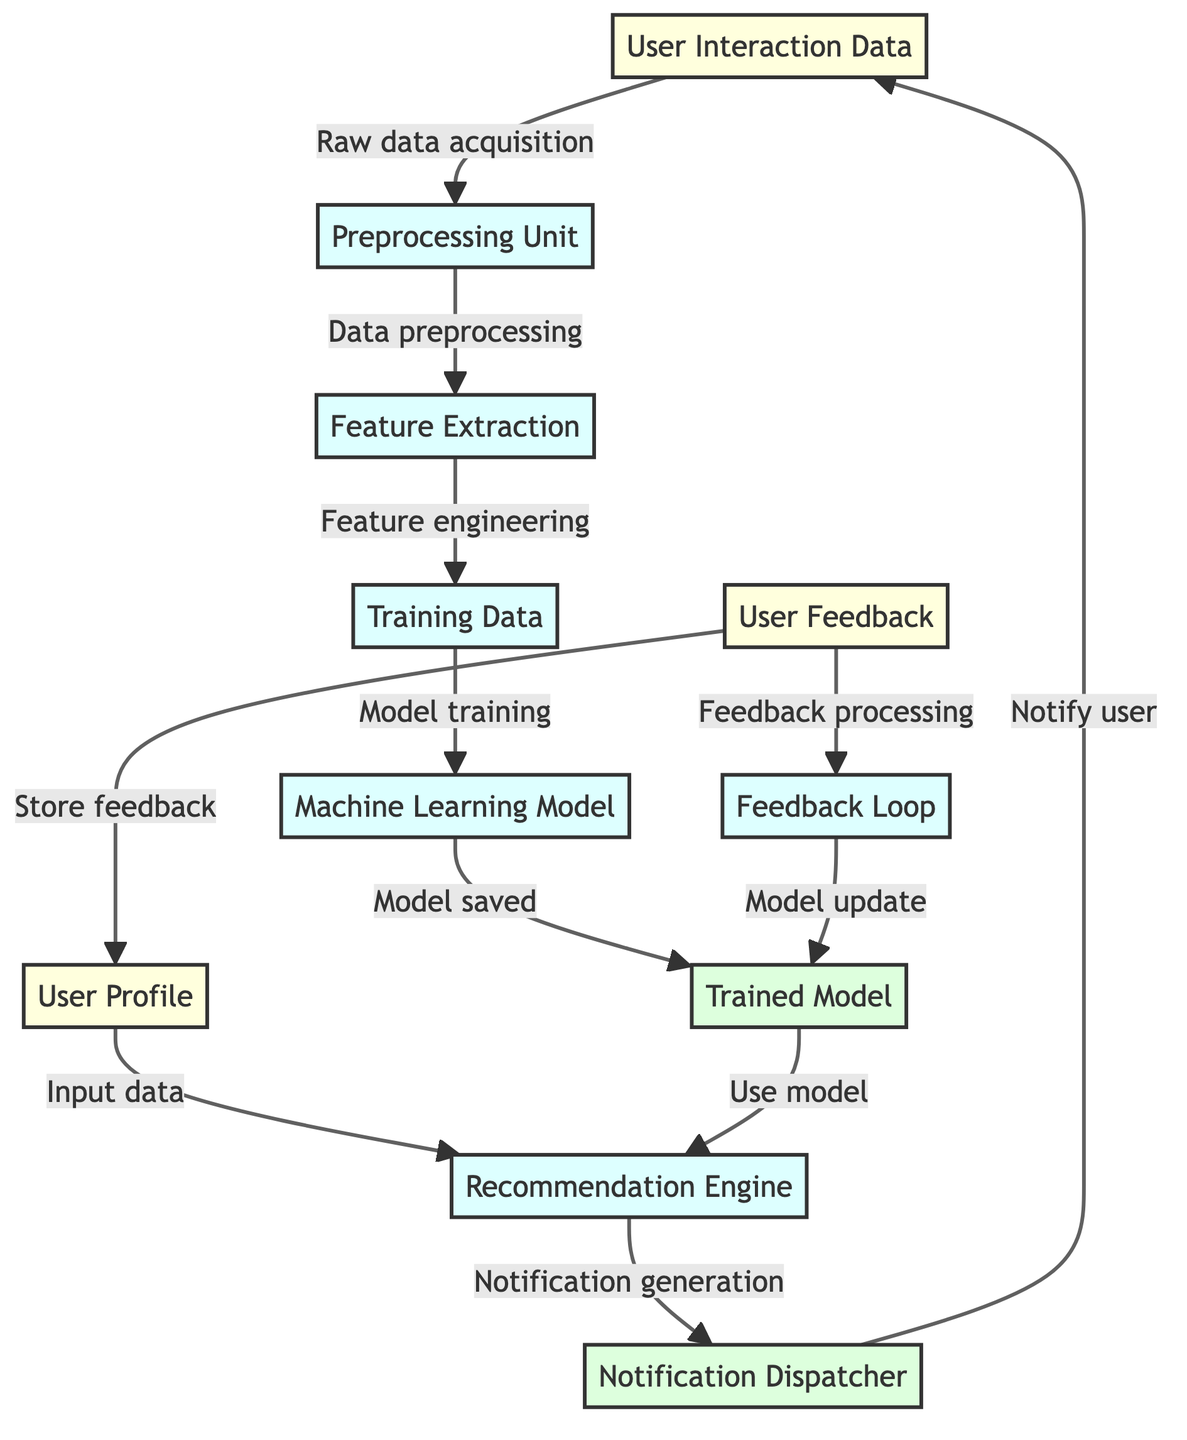What is the first step in the workflow? The first step in the workflow is "User Interaction Data," where raw data is collected from user interactions.
Answer: User Interaction Data How many input nodes are there in the diagram? There are three input nodes: "User Interaction Data," "User Profile," and "User Feedback."
Answer: 3 What is the relationship between the "Trained Model" and the "Recommendation Engine"? The "Trained Model" is used by the "Recommendation Engine" to generate notifications based on the user profile data.
Answer: Use model What process follows "Feature Extraction"? The process that follows "Feature Extraction" is "Training Data," where data is prepared for model training.
Answer: Training Data What does the "Notification Dispatcher" do? The "Notification Dispatcher" is responsible for notifying the user once the notifications are generated.
Answer: Notify user After receiving "User Feedback," what does the flow lead to? After receiving "User Feedback," the flow leads to the "Feedback Processing" which then goes to the "Feedback Loop" for model updates.
Answer: Feedback Loop How many total processes are represented in the diagram? There are five processes: "Preprocessing Unit," "Feature Extraction," "Training Data," "Machine Learning Model," and "Recommendation Engine."
Answer: 5 What is the purpose of "Feedback Loop"? The "Feedback Loop" updates the "Trained Model" based on the feedback collected from users, refining the system.
Answer: Model update Which node generates notifications? The "Recommendation Engine" generates notifications before passing them on to the "Notification Dispatcher."
Answer: Notification generation 